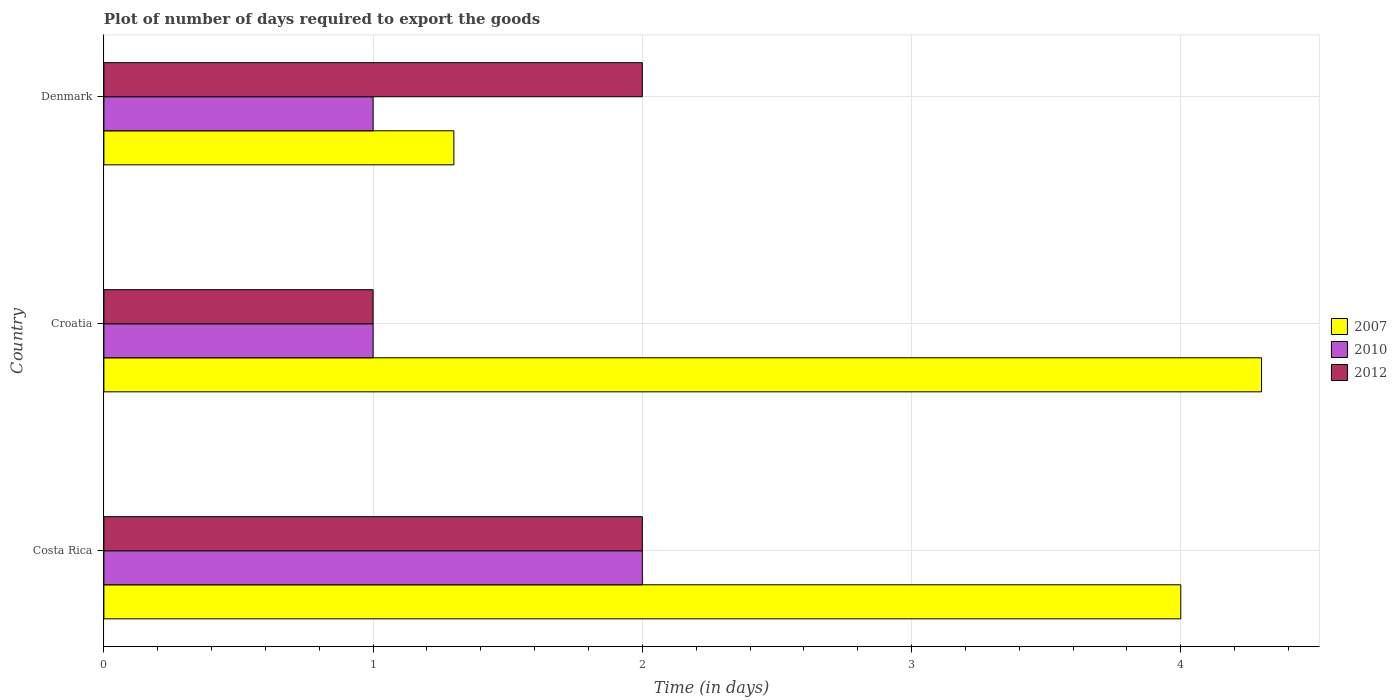How many different coloured bars are there?
Your answer should be compact. 3. How many groups of bars are there?
Give a very brief answer. 3. In how many cases, is the number of bars for a given country not equal to the number of legend labels?
Ensure brevity in your answer.  0. Across all countries, what is the maximum time required to export goods in 2012?
Provide a short and direct response. 2. Across all countries, what is the minimum time required to export goods in 2007?
Provide a succinct answer. 1.3. In which country was the time required to export goods in 2012 minimum?
Give a very brief answer. Croatia. What is the total time required to export goods in 2007 in the graph?
Give a very brief answer. 9.6. What is the difference between the time required to export goods in 2007 in Costa Rica and that in Croatia?
Give a very brief answer. -0.3. What is the average time required to export goods in 2010 per country?
Your response must be concise. 1.33. What is the ratio of the time required to export goods in 2007 in Croatia to that in Denmark?
Your response must be concise. 3.31. Is the difference between the time required to export goods in 2007 in Costa Rica and Denmark greater than the difference between the time required to export goods in 2010 in Costa Rica and Denmark?
Offer a terse response. Yes. What is the difference between the highest and the second highest time required to export goods in 2012?
Provide a short and direct response. 0. What is the difference between the highest and the lowest time required to export goods in 2012?
Your answer should be very brief. 1. Is the sum of the time required to export goods in 2012 in Costa Rica and Croatia greater than the maximum time required to export goods in 2007 across all countries?
Offer a very short reply. No. What does the 2nd bar from the bottom in Costa Rica represents?
Offer a terse response. 2010. Is it the case that in every country, the sum of the time required to export goods in 2007 and time required to export goods in 2010 is greater than the time required to export goods in 2012?
Keep it short and to the point. Yes. How many countries are there in the graph?
Provide a short and direct response. 3. Are the values on the major ticks of X-axis written in scientific E-notation?
Ensure brevity in your answer.  No. How many legend labels are there?
Ensure brevity in your answer.  3. How are the legend labels stacked?
Make the answer very short. Vertical. What is the title of the graph?
Provide a short and direct response. Plot of number of days required to export the goods. What is the label or title of the X-axis?
Give a very brief answer. Time (in days). What is the label or title of the Y-axis?
Your response must be concise. Country. What is the Time (in days) in 2007 in Costa Rica?
Keep it short and to the point. 4. What is the Time (in days) of 2010 in Costa Rica?
Make the answer very short. 2. What is the Time (in days) in 2007 in Croatia?
Ensure brevity in your answer.  4.3. What is the Time (in days) in 2012 in Croatia?
Provide a succinct answer. 1. Across all countries, what is the minimum Time (in days) in 2010?
Keep it short and to the point. 1. What is the total Time (in days) of 2010 in the graph?
Provide a short and direct response. 4. What is the total Time (in days) of 2012 in the graph?
Provide a succinct answer. 5. What is the difference between the Time (in days) of 2012 in Costa Rica and that in Croatia?
Offer a very short reply. 1. What is the difference between the Time (in days) of 2007 in Croatia and that in Denmark?
Your answer should be very brief. 3. What is the difference between the Time (in days) of 2012 in Croatia and that in Denmark?
Your answer should be very brief. -1. What is the difference between the Time (in days) of 2007 in Costa Rica and the Time (in days) of 2010 in Croatia?
Your answer should be compact. 3. What is the difference between the Time (in days) in 2007 in Costa Rica and the Time (in days) in 2012 in Croatia?
Ensure brevity in your answer.  3. What is the difference between the Time (in days) in 2010 in Costa Rica and the Time (in days) in 2012 in Croatia?
Provide a short and direct response. 1. What is the difference between the Time (in days) of 2007 in Costa Rica and the Time (in days) of 2010 in Denmark?
Your answer should be very brief. 3. What is the difference between the Time (in days) of 2007 in Croatia and the Time (in days) of 2012 in Denmark?
Offer a very short reply. 2.3. What is the average Time (in days) of 2007 per country?
Give a very brief answer. 3.2. What is the difference between the Time (in days) of 2007 and Time (in days) of 2010 in Costa Rica?
Keep it short and to the point. 2. What is the difference between the Time (in days) in 2010 and Time (in days) in 2012 in Costa Rica?
Make the answer very short. 0. What is the difference between the Time (in days) of 2007 and Time (in days) of 2012 in Croatia?
Provide a succinct answer. 3.3. What is the difference between the Time (in days) of 2007 and Time (in days) of 2010 in Denmark?
Offer a terse response. 0.3. What is the difference between the Time (in days) of 2010 and Time (in days) of 2012 in Denmark?
Provide a succinct answer. -1. What is the ratio of the Time (in days) in 2007 in Costa Rica to that in Croatia?
Your answer should be very brief. 0.93. What is the ratio of the Time (in days) in 2007 in Costa Rica to that in Denmark?
Offer a very short reply. 3.08. What is the ratio of the Time (in days) of 2012 in Costa Rica to that in Denmark?
Your answer should be very brief. 1. What is the ratio of the Time (in days) of 2007 in Croatia to that in Denmark?
Ensure brevity in your answer.  3.31. What is the ratio of the Time (in days) in 2010 in Croatia to that in Denmark?
Make the answer very short. 1. What is the difference between the highest and the second highest Time (in days) in 2007?
Your answer should be compact. 0.3. What is the difference between the highest and the lowest Time (in days) of 2007?
Ensure brevity in your answer.  3. What is the difference between the highest and the lowest Time (in days) of 2012?
Ensure brevity in your answer.  1. 